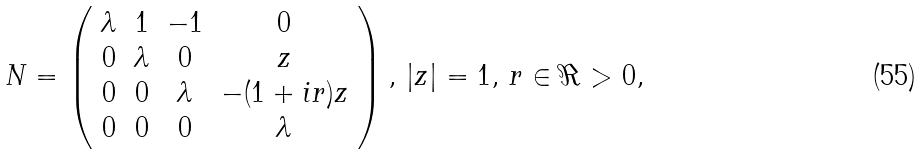Convert formula to latex. <formula><loc_0><loc_0><loc_500><loc_500>N = \left ( \begin{array} { c c c c c } \lambda & 1 & - 1 & 0 \\ 0 & \lambda & 0 & z \\ 0 & 0 & \lambda & - ( 1 + i r ) z \\ 0 & 0 & 0 & \lambda \end{array} \right ) , \, | z | = 1 , \, r \in \Re > 0 ,</formula> 